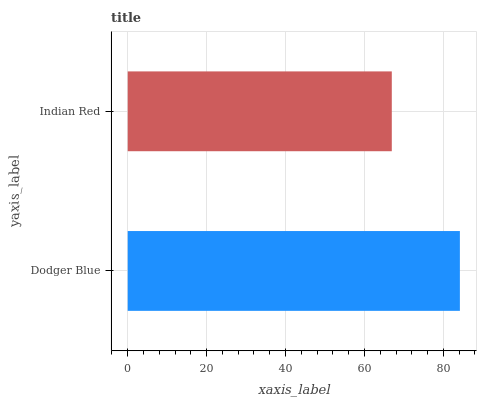Is Indian Red the minimum?
Answer yes or no. Yes. Is Dodger Blue the maximum?
Answer yes or no. Yes. Is Indian Red the maximum?
Answer yes or no. No. Is Dodger Blue greater than Indian Red?
Answer yes or no. Yes. Is Indian Red less than Dodger Blue?
Answer yes or no. Yes. Is Indian Red greater than Dodger Blue?
Answer yes or no. No. Is Dodger Blue less than Indian Red?
Answer yes or no. No. Is Dodger Blue the high median?
Answer yes or no. Yes. Is Indian Red the low median?
Answer yes or no. Yes. Is Indian Red the high median?
Answer yes or no. No. Is Dodger Blue the low median?
Answer yes or no. No. 